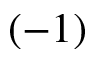Convert formula to latex. <formula><loc_0><loc_0><loc_500><loc_500>( - 1 )</formula> 